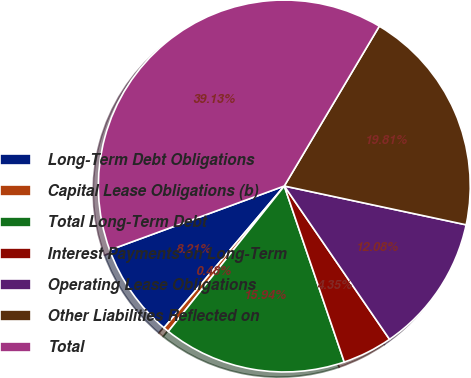Convert chart. <chart><loc_0><loc_0><loc_500><loc_500><pie_chart><fcel>Long-Term Debt Obligations<fcel>Capital Lease Obligations (b)<fcel>Total Long-Term Debt<fcel>Interest Payments on Long-Term<fcel>Operating Lease Obligations<fcel>Other Liabilities Reflected on<fcel>Total<nl><fcel>8.21%<fcel>0.48%<fcel>15.94%<fcel>4.35%<fcel>12.08%<fcel>19.81%<fcel>39.13%<nl></chart> 